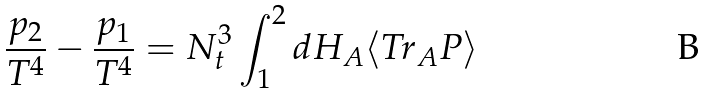Convert formula to latex. <formula><loc_0><loc_0><loc_500><loc_500>\frac { p _ { 2 } } { T ^ { 4 } } - \frac { p _ { 1 } } { T ^ { 4 } } = N _ { t } ^ { 3 } \int _ { 1 } ^ { 2 } d H _ { A } \langle T r _ { A } P \rangle</formula> 